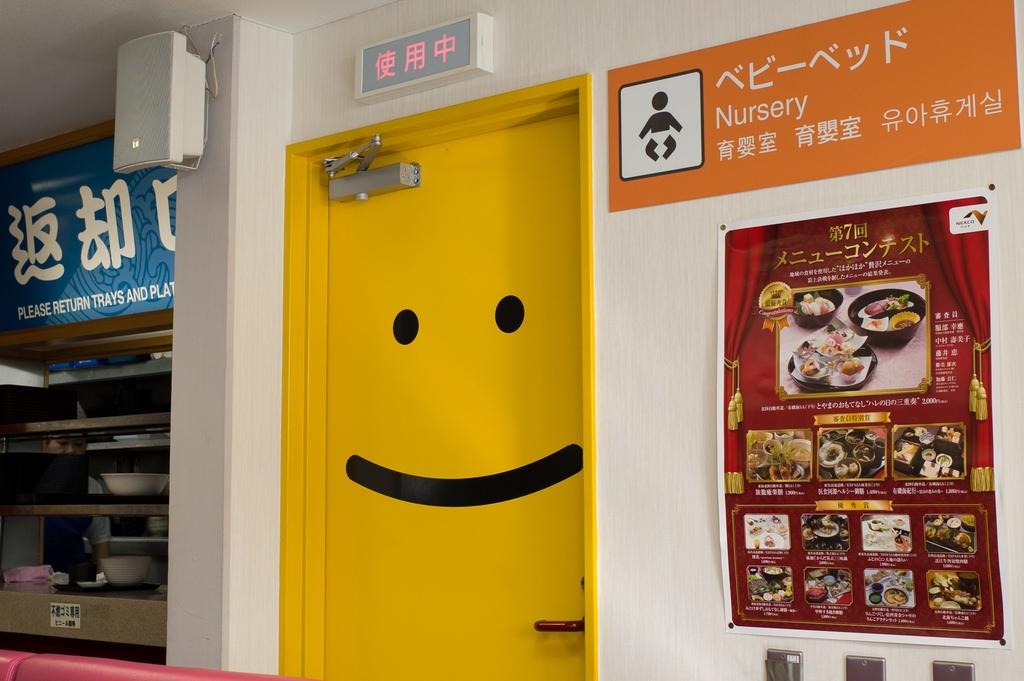What kind of room is this?
Keep it short and to the point. Nursery. What is the last line on the blue sign on the left?
Offer a terse response. Please return trays and plates. 